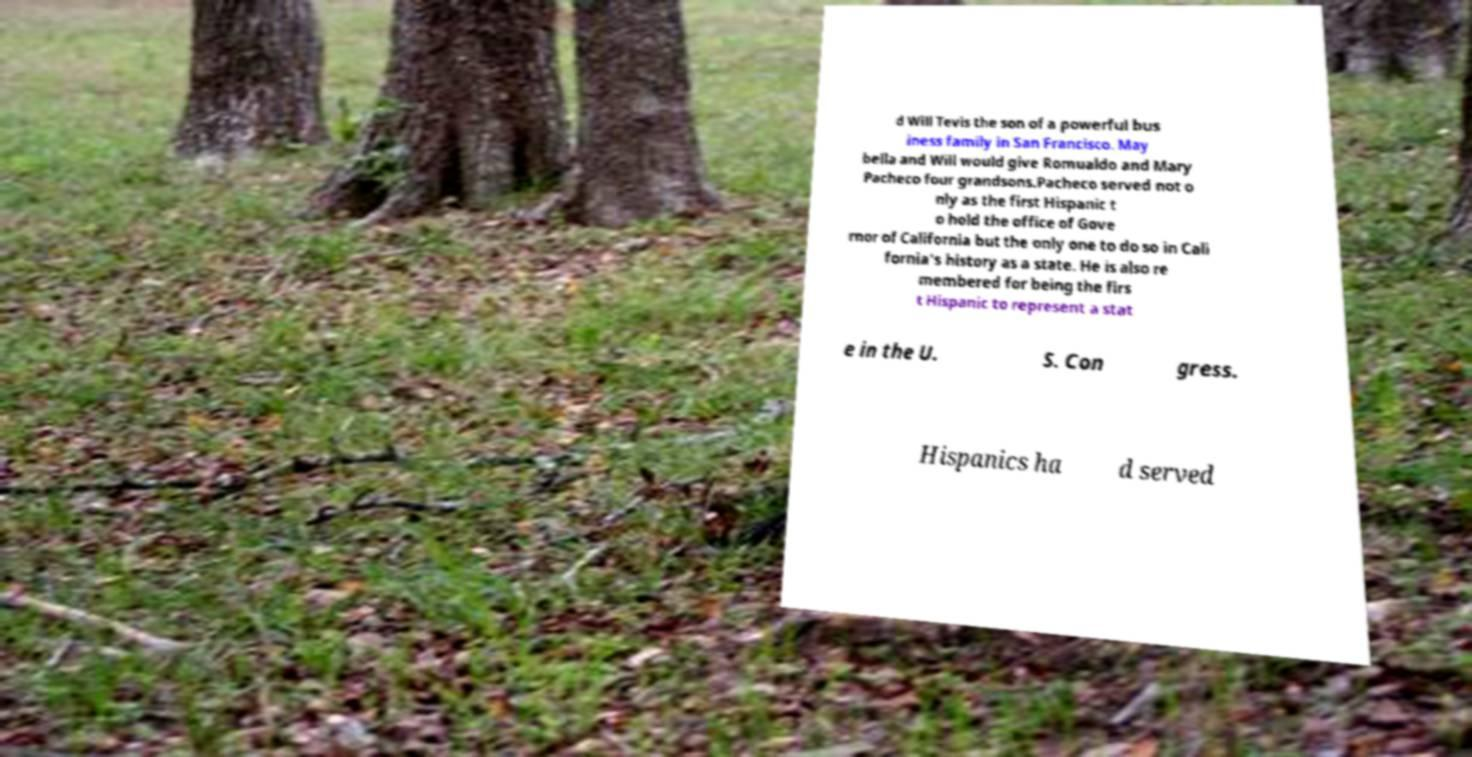For documentation purposes, I need the text within this image transcribed. Could you provide that? d Will Tevis the son of a powerful bus iness family in San Francisco. May bella and Will would give Romualdo and Mary Pacheco four grandsons.Pacheco served not o nly as the first Hispanic t o hold the office of Gove rnor of California but the only one to do so in Cali fornia's history as a state. He is also re membered for being the firs t Hispanic to represent a stat e in the U. S. Con gress. Hispanics ha d served 